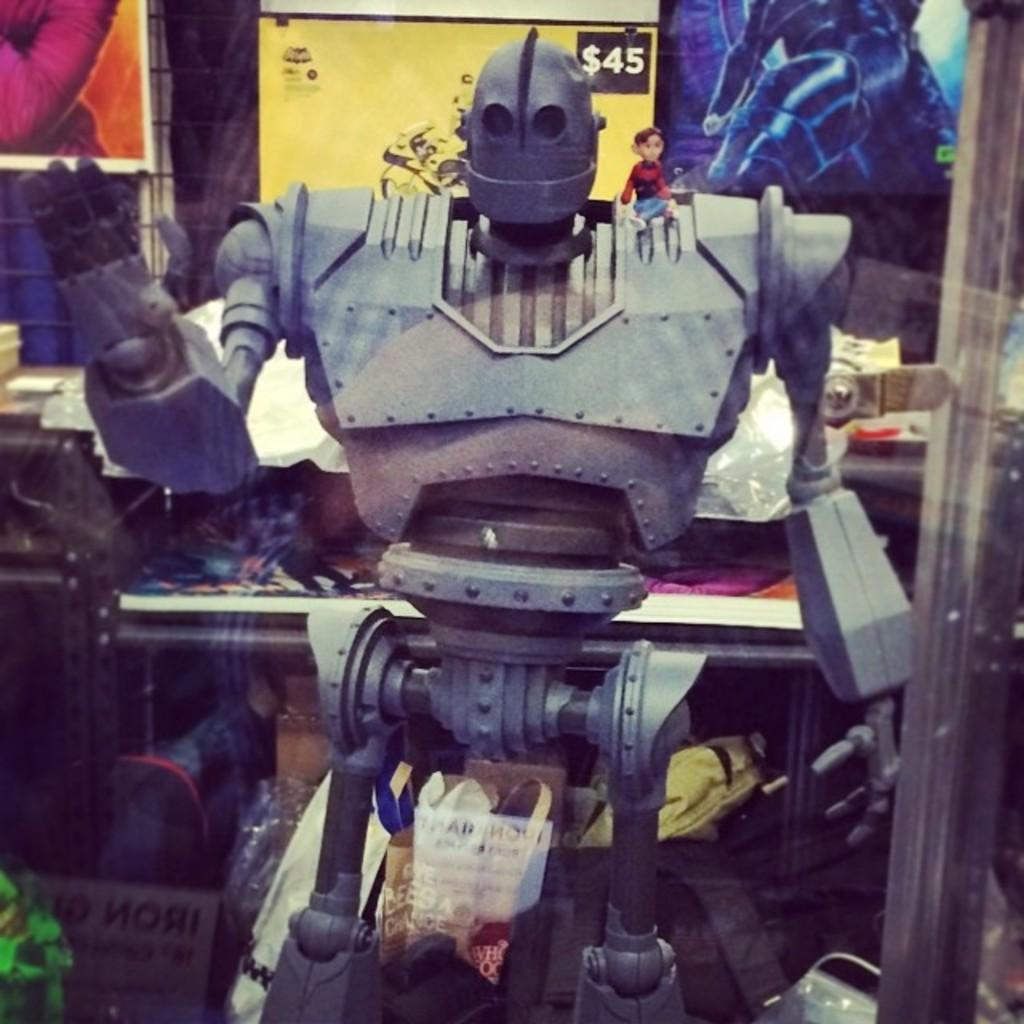What is the main subject of the picture? The main subject of the picture is a robot. What else can be seen in the picture besides the robot? There are boards and other objects in the picture. What type of treatment is the robot receiving in the picture? There is no indication in the image that the robot is receiving any treatment. 